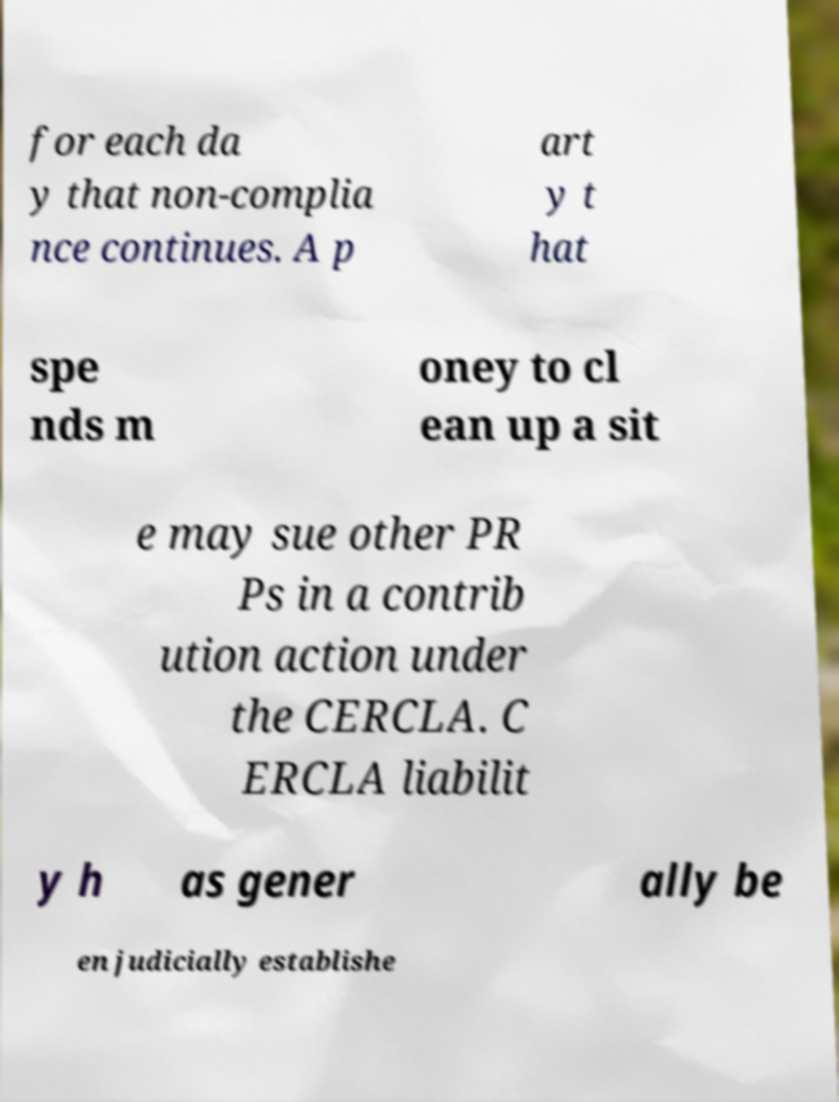What messages or text are displayed in this image? I need them in a readable, typed format. for each da y that non-complia nce continues. A p art y t hat spe nds m oney to cl ean up a sit e may sue other PR Ps in a contrib ution action under the CERCLA. C ERCLA liabilit y h as gener ally be en judicially establishe 